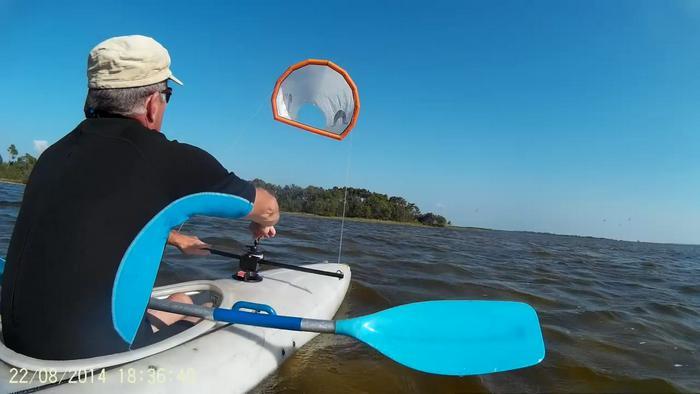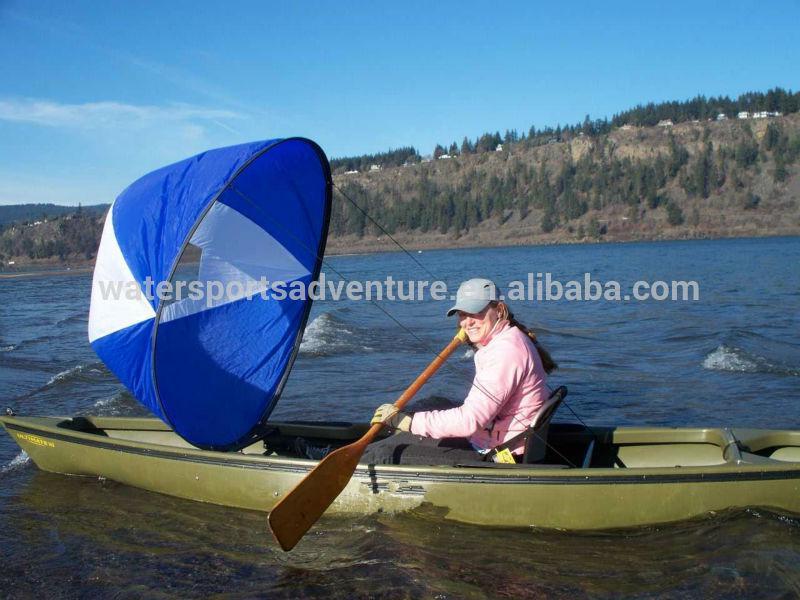The first image is the image on the left, the second image is the image on the right. Given the left and right images, does the statement "One of the boats appears to have been grounded on the beach; the boat can easily be used again later." hold true? Answer yes or no. No. 